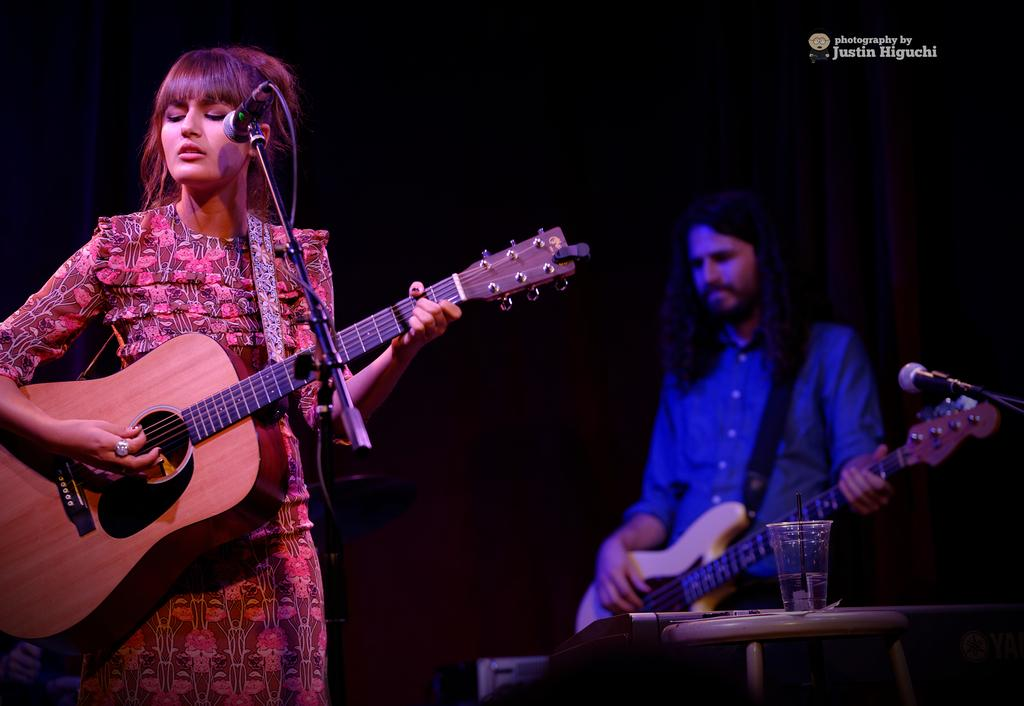What is the overall color scheme of the image? The background of the image is dark. How many people are in the image? There is a man and a woman in the image. What are the man and woman doing in the image? Both the man and woman are standing in front of a microphone. What instrument is the man playing? The man is playing a guitar. Can you describe any other objects in the image? There is a glass of water on a table. Where is the iron located in the image? There is no iron present in the image. What type of shelf can be seen in the image? There is no shelf present in the image. 